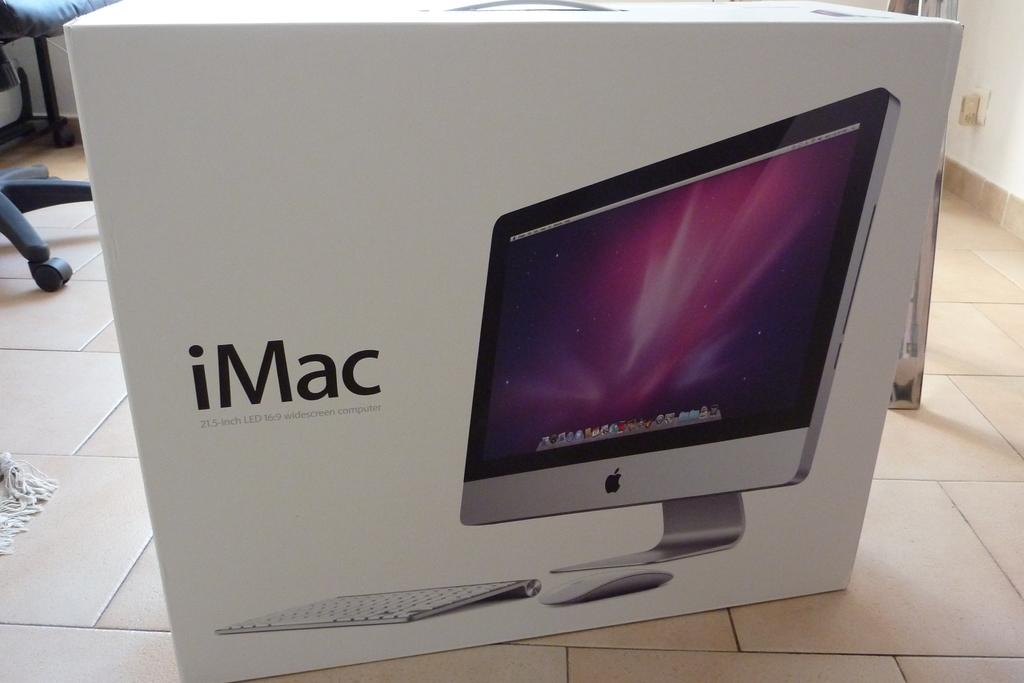Provide a one-sentence caption for the provided image. imac computer that is new in a white box that never been open. 